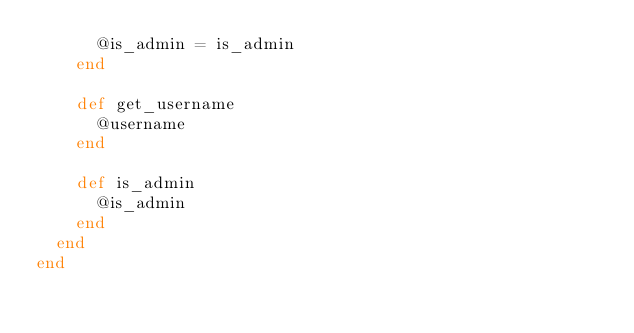Convert code to text. <code><loc_0><loc_0><loc_500><loc_500><_Ruby_>      @is_admin = is_admin
    end

    def get_username
      @username
    end

    def is_admin
      @is_admin
    end
  end
end
</code> 